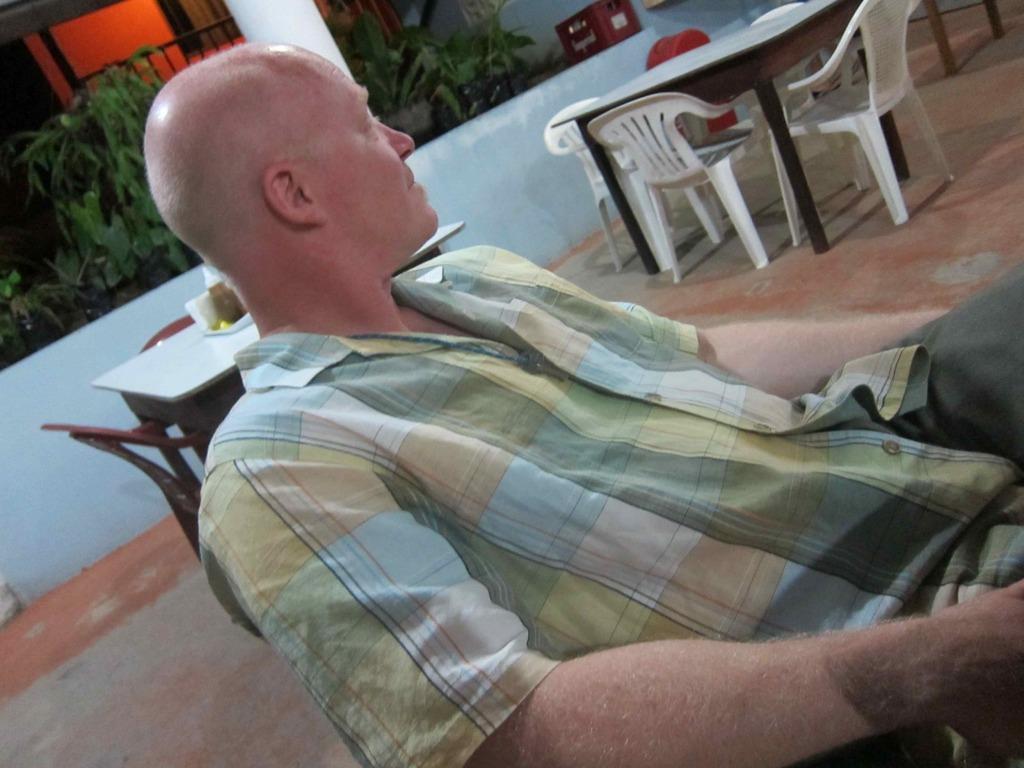In one or two sentences, can you explain what this image depicts? In this image we can see a man sitting. In the background there are tables and chairs. We can see planets and a wall. 